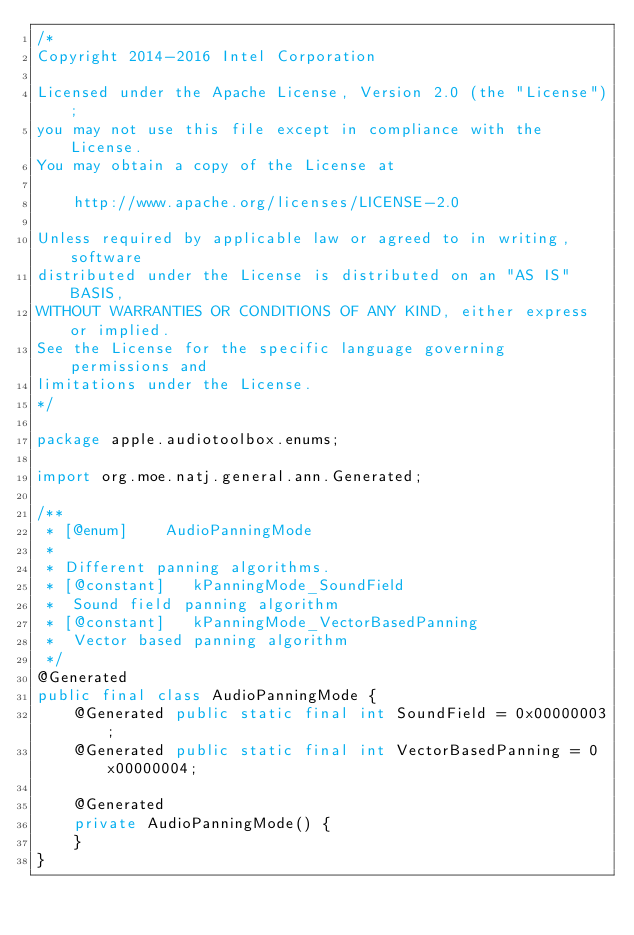Convert code to text. <code><loc_0><loc_0><loc_500><loc_500><_Java_>/*
Copyright 2014-2016 Intel Corporation

Licensed under the Apache License, Version 2.0 (the "License");
you may not use this file except in compliance with the License.
You may obtain a copy of the License at

    http://www.apache.org/licenses/LICENSE-2.0

Unless required by applicable law or agreed to in writing, software
distributed under the License is distributed on an "AS IS" BASIS,
WITHOUT WARRANTIES OR CONDITIONS OF ANY KIND, either express or implied.
See the License for the specific language governing permissions and
limitations under the License.
*/

package apple.audiotoolbox.enums;

import org.moe.natj.general.ann.Generated;

/**
 * [@enum]		AudioPanningMode
 * 
 * Different panning algorithms.
 * [@constant]   kPanningMode_SoundField
 * 	Sound field panning algorithm
 * [@constant]   kPanningMode_VectorBasedPanning
 * 	Vector based panning algorithm
 */
@Generated
public final class AudioPanningMode {
    @Generated public static final int SoundField = 0x00000003;
    @Generated public static final int VectorBasedPanning = 0x00000004;

    @Generated
    private AudioPanningMode() {
    }
}
</code> 